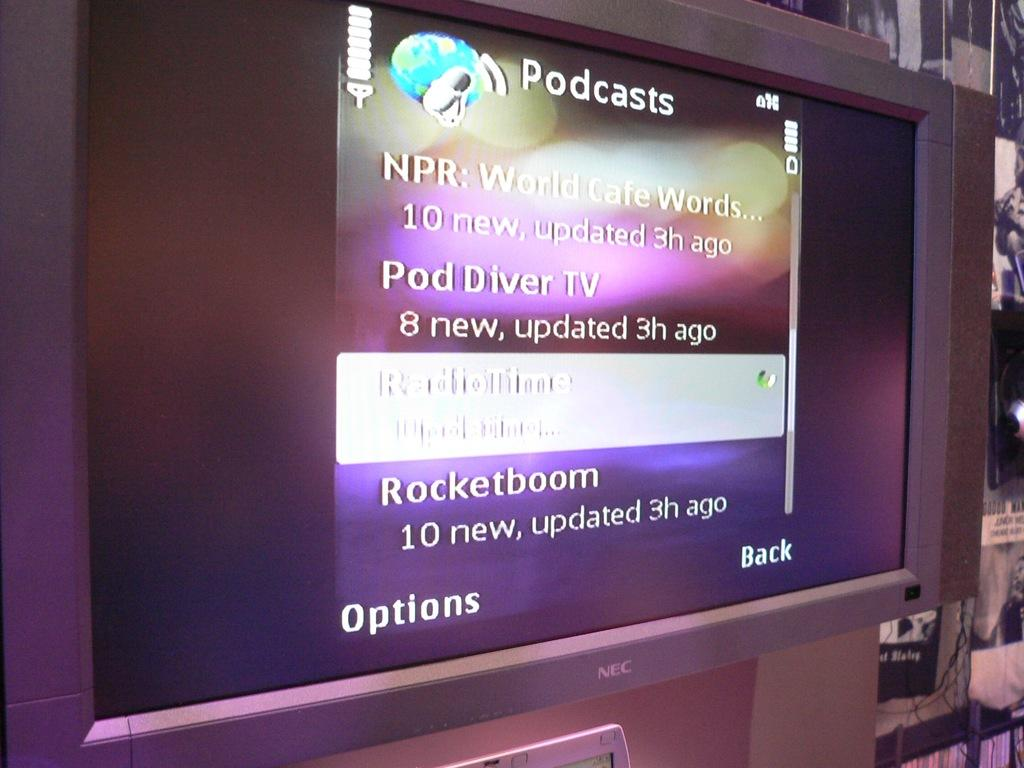Provide a one-sentence caption for the provided image. A screen shows a lists of podcasts on a purple background. 